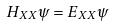Convert formula to latex. <formula><loc_0><loc_0><loc_500><loc_500>H _ { X X } \psi = E _ { X X } \psi</formula> 